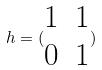Convert formula to latex. <formula><loc_0><loc_0><loc_500><loc_500>h = ( \begin{matrix} 1 & 1 \\ 0 & 1 \end{matrix} )</formula> 